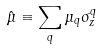Convert formula to latex. <formula><loc_0><loc_0><loc_500><loc_500>\hat { \mu } \equiv \sum _ { q } \mu _ { q } \sigma _ { z } ^ { q }</formula> 